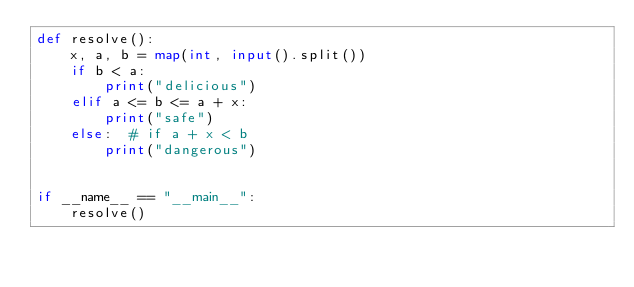Convert code to text. <code><loc_0><loc_0><loc_500><loc_500><_Python_>def resolve():
    x, a, b = map(int, input().split())
    if b < a:
        print("delicious")
    elif a <= b <= a + x:
        print("safe")
    else:  # if a + x < b
        print("dangerous")


if __name__ == "__main__":
    resolve()
</code> 